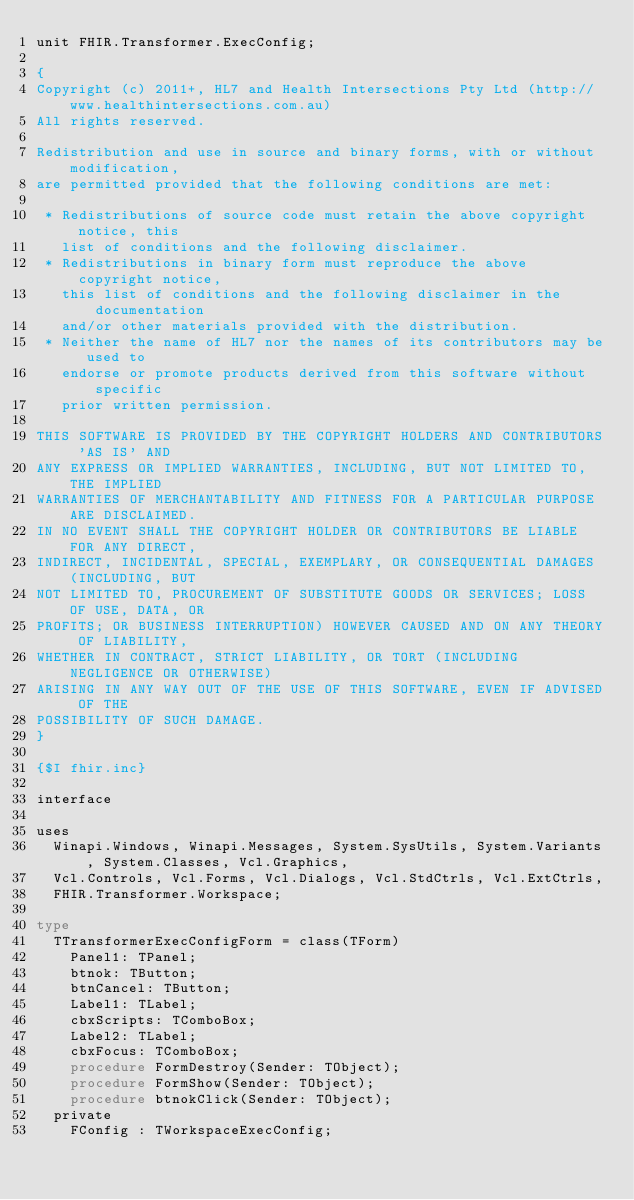<code> <loc_0><loc_0><loc_500><loc_500><_Pascal_>unit FHIR.Transformer.ExecConfig;

{
Copyright (c) 2011+, HL7 and Health Intersections Pty Ltd (http://www.healthintersections.com.au)
All rights reserved.

Redistribution and use in source and binary forms, with or without modification,
are permitted provided that the following conditions are met:

 * Redistributions of source code must retain the above copyright notice, this
   list of conditions and the following disclaimer.
 * Redistributions in binary form must reproduce the above copyright notice,
   this list of conditions and the following disclaimer in the documentation
   and/or other materials provided with the distribution.
 * Neither the name of HL7 nor the names of its contributors may be used to
   endorse or promote products derived from this software without specific
   prior written permission.

THIS SOFTWARE IS PROVIDED BY THE COPYRIGHT HOLDERS AND CONTRIBUTORS 'AS IS' AND
ANY EXPRESS OR IMPLIED WARRANTIES, INCLUDING, BUT NOT LIMITED TO, THE IMPLIED
WARRANTIES OF MERCHANTABILITY AND FITNESS FOR A PARTICULAR PURPOSE ARE DISCLAIMED.
IN NO EVENT SHALL THE COPYRIGHT HOLDER OR CONTRIBUTORS BE LIABLE FOR ANY DIRECT,
INDIRECT, INCIDENTAL, SPECIAL, EXEMPLARY, OR CONSEQUENTIAL DAMAGES (INCLUDING, BUT
NOT LIMITED TO, PROCUREMENT OF SUBSTITUTE GOODS OR SERVICES; LOSS OF USE, DATA, OR
PROFITS; OR BUSINESS INTERRUPTION) HOWEVER CAUSED AND ON ANY THEORY OF LIABILITY,
WHETHER IN CONTRACT, STRICT LIABILITY, OR TORT (INCLUDING NEGLIGENCE OR OTHERWISE)
ARISING IN ANY WAY OUT OF THE USE OF THIS SOFTWARE, EVEN IF ADVISED OF THE
POSSIBILITY OF SUCH DAMAGE.
}

{$I fhir.inc}

interface

uses
  Winapi.Windows, Winapi.Messages, System.SysUtils, System.Variants, System.Classes, Vcl.Graphics,
  Vcl.Controls, Vcl.Forms, Vcl.Dialogs, Vcl.StdCtrls, Vcl.ExtCtrls,
  FHIR.Transformer.Workspace;

type
  TTransformerExecConfigForm = class(TForm)
    Panel1: TPanel;
    btnok: TButton;
    btnCancel: TButton;
    Label1: TLabel;
    cbxScripts: TComboBox;
    Label2: TLabel;
    cbxFocus: TComboBox;
    procedure FormDestroy(Sender: TObject);
    procedure FormShow(Sender: TObject);
    procedure btnokClick(Sender: TObject);
  private
    FConfig : TWorkspaceExecConfig;</code> 